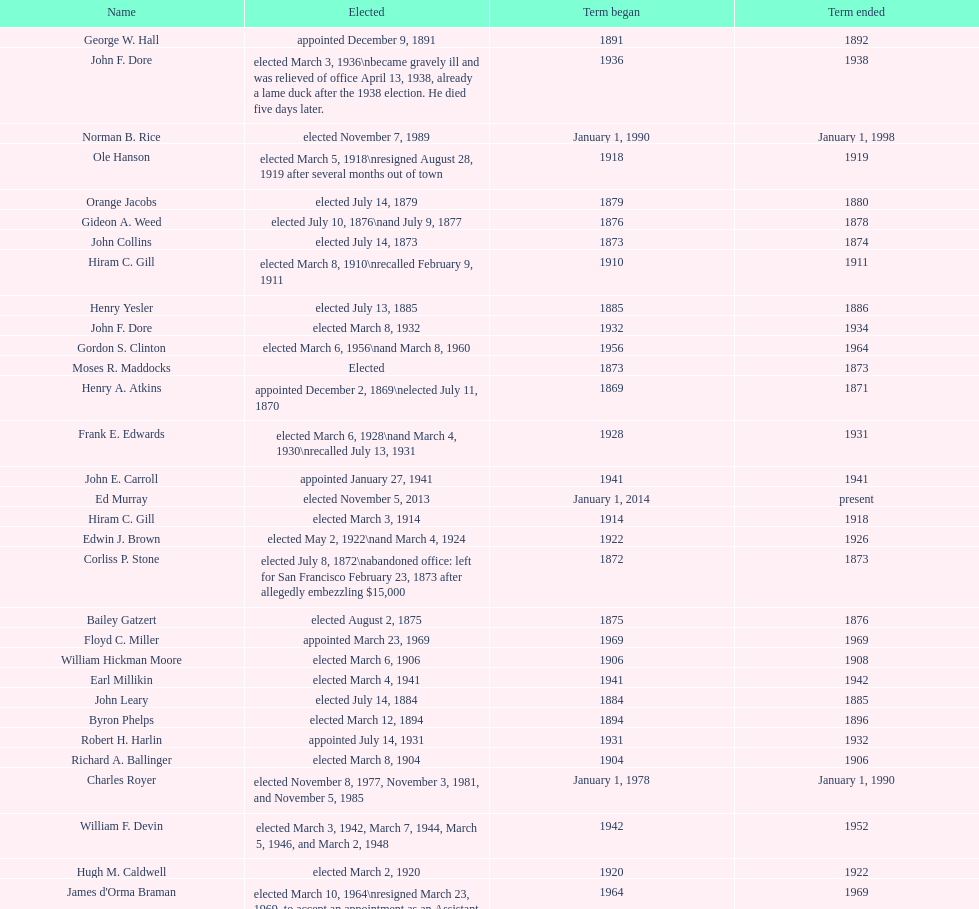What is the number of mayors with the first name of john? 6. 